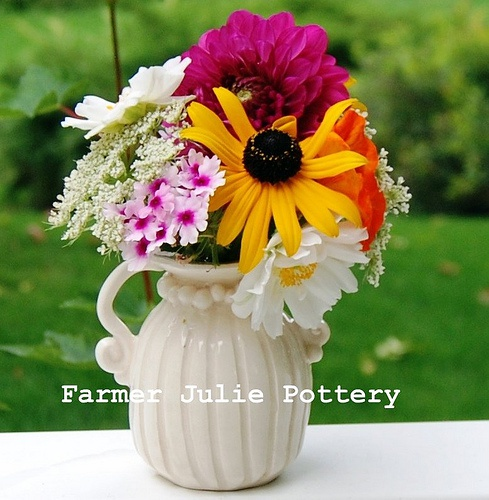Describe the objects in this image and their specific colors. I can see a vase in darkgreen, darkgray, and lightgray tones in this image. 